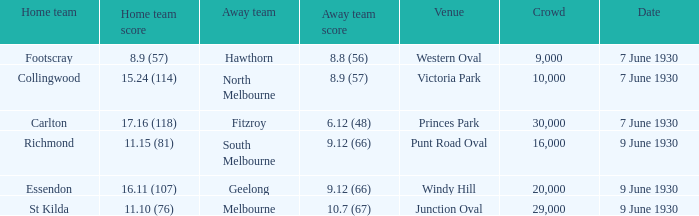Where did the away team score 8.9 (57)? Victoria Park. 